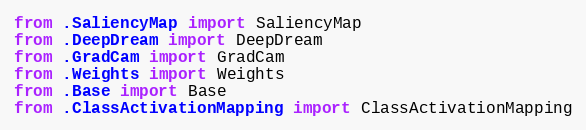Convert code to text. <code><loc_0><loc_0><loc_500><loc_500><_Python_>from .SaliencyMap import SaliencyMap
from .DeepDream import DeepDream
from .GradCam import GradCam
from .Weights import Weights
from .Base import Base
from .ClassActivationMapping import ClassActivationMapping
</code> 